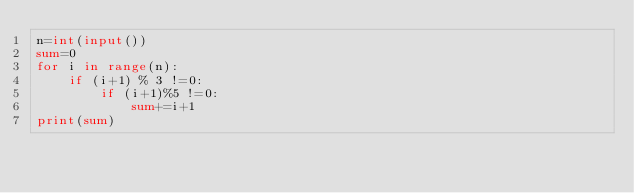<code> <loc_0><loc_0><loc_500><loc_500><_Python_>n=int(input())
sum=0
for i in range(n):
	if (i+1) % 3 !=0:
		if (i+1)%5 !=0:
			sum+=i+1
print(sum)</code> 